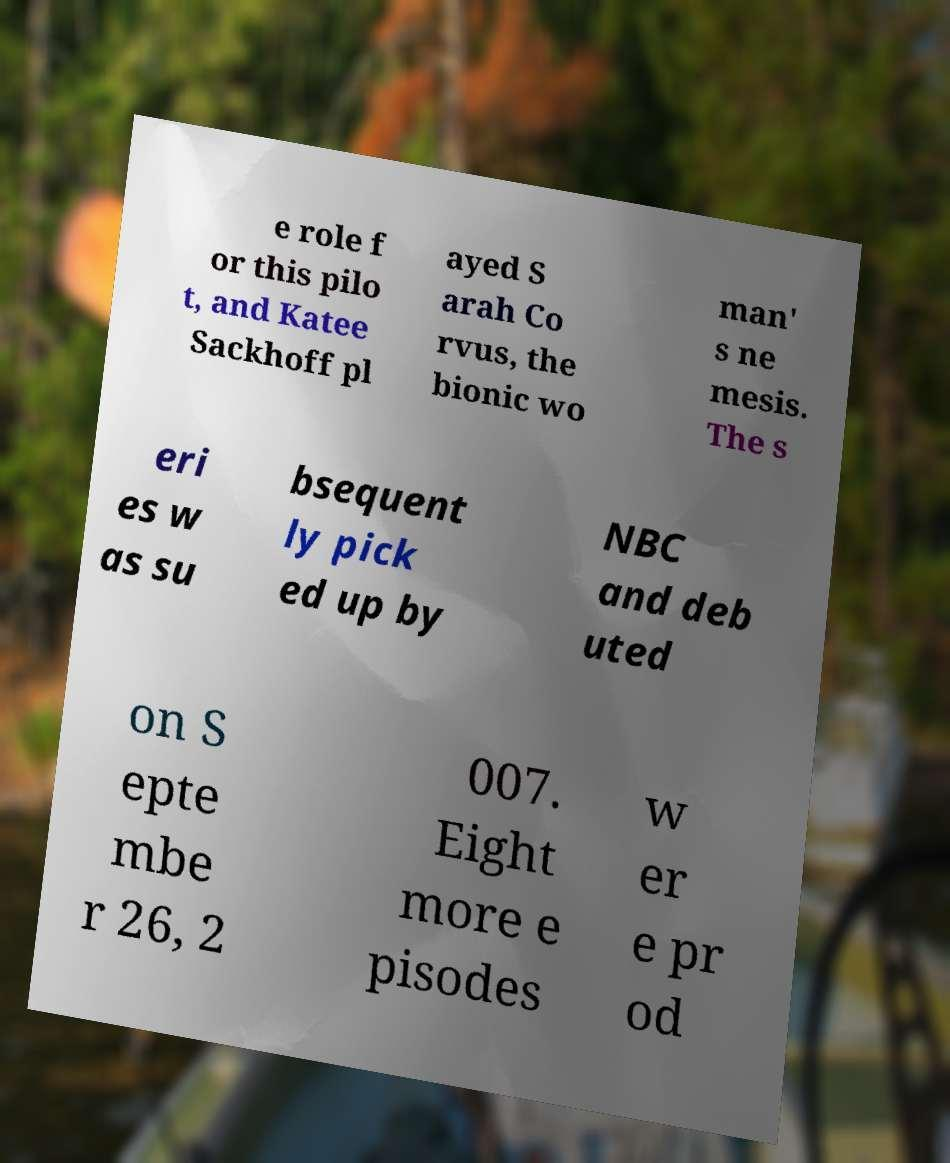Could you extract and type out the text from this image? e role f or this pilo t, and Katee Sackhoff pl ayed S arah Co rvus, the bionic wo man' s ne mesis. The s eri es w as su bsequent ly pick ed up by NBC and deb uted on S epte mbe r 26, 2 007. Eight more e pisodes w er e pr od 